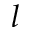<formula> <loc_0><loc_0><loc_500><loc_500>l</formula> 